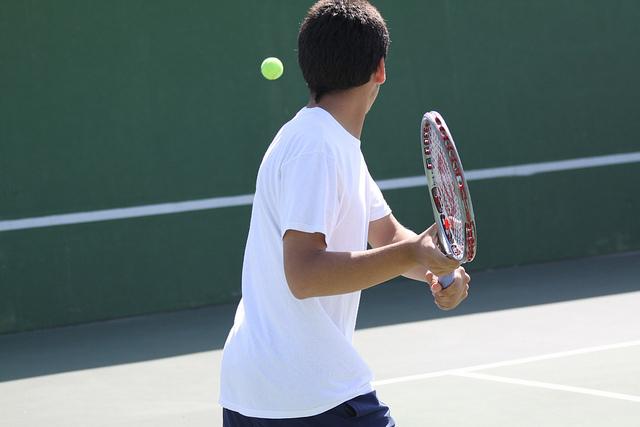What kind of ball is it?
Short answer required. Tennis. What is the man holding in his hands?
Be succinct. Tennis racket. What color is the wall?
Quick response, please. Green. 